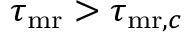<formula> <loc_0><loc_0><loc_500><loc_500>\tau _ { m r } > \tau _ { { m r } , c }</formula> 